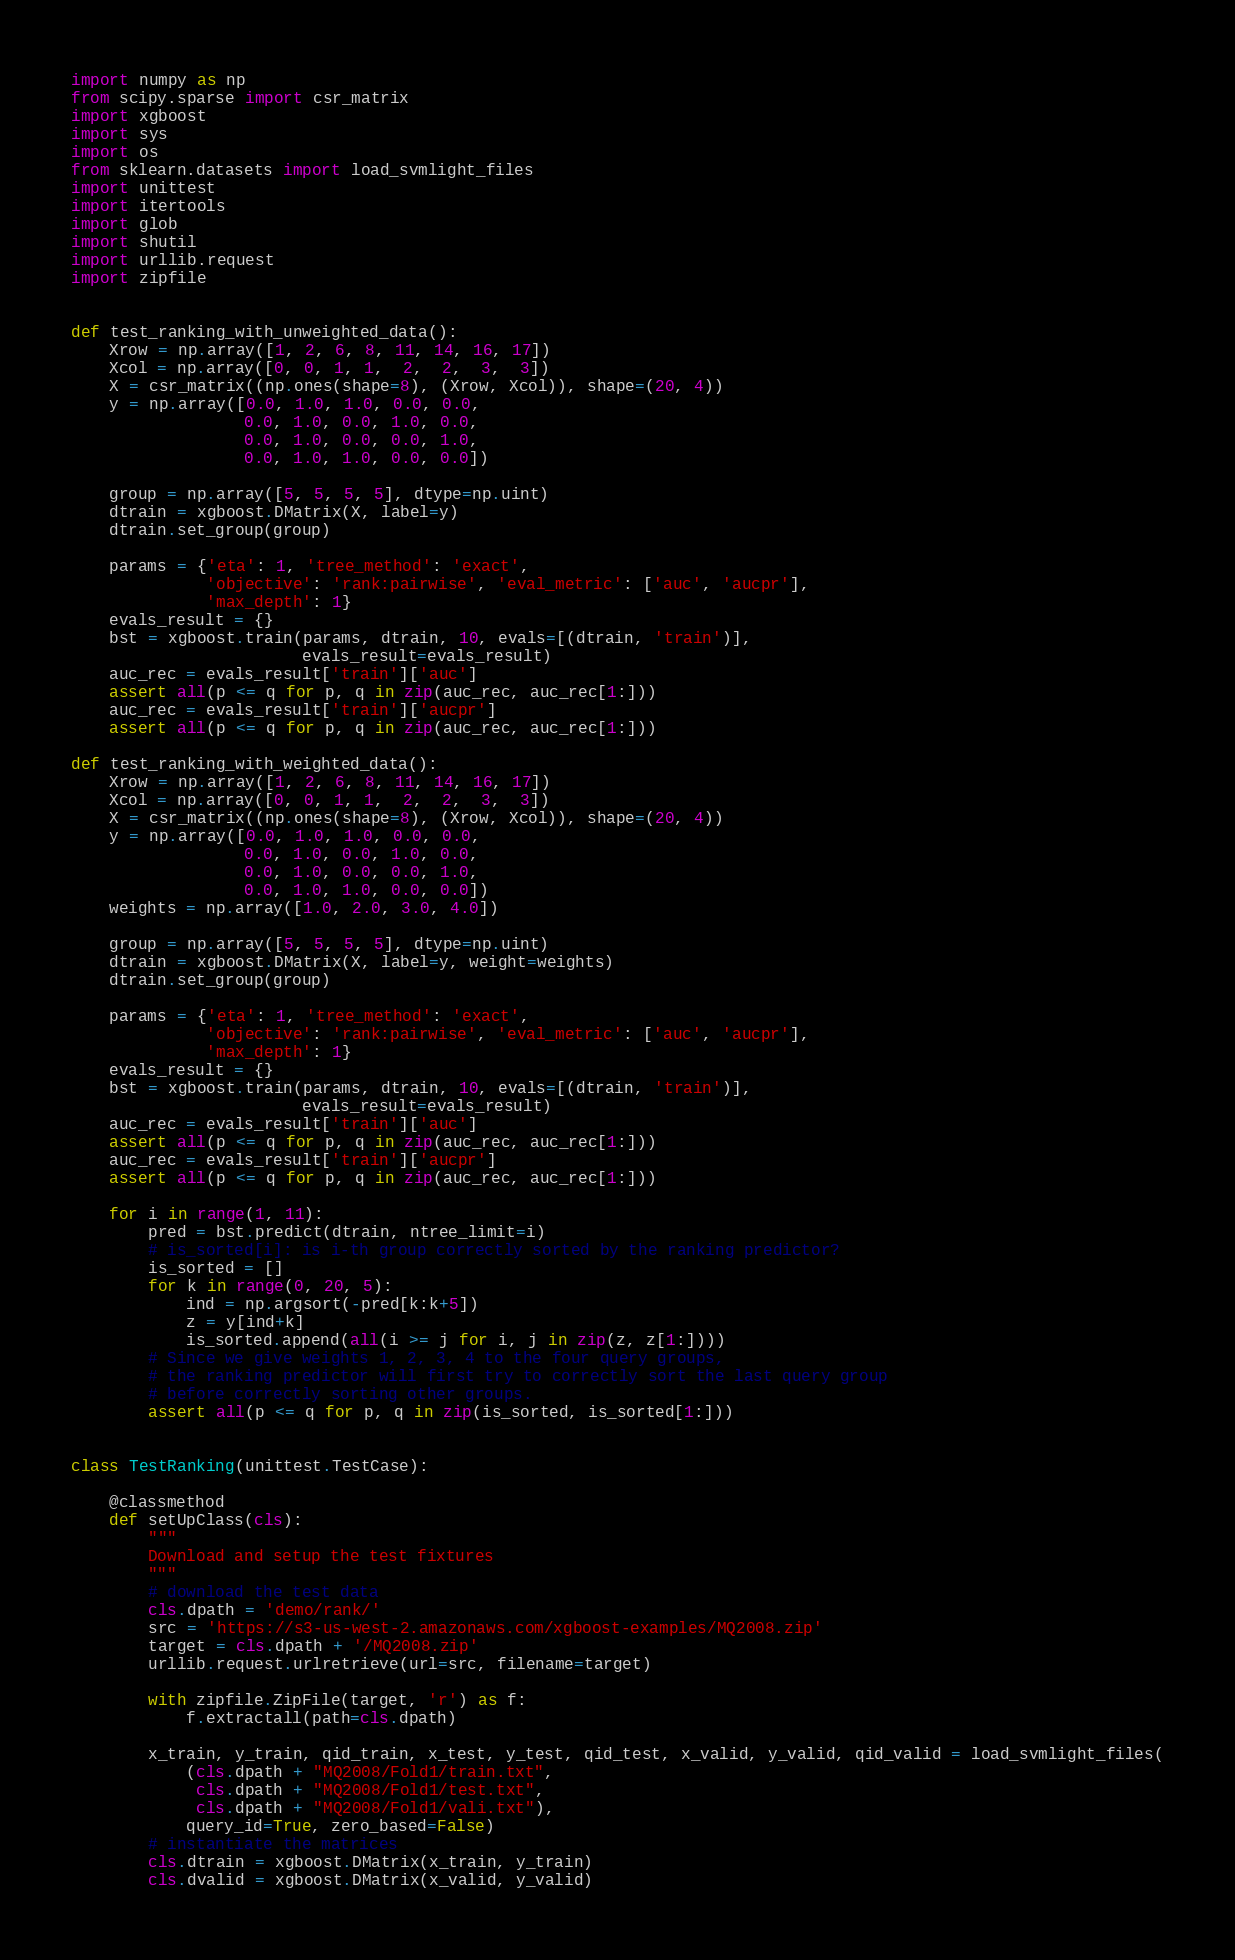<code> <loc_0><loc_0><loc_500><loc_500><_Python_>import numpy as np
from scipy.sparse import csr_matrix
import xgboost
import sys
import os
from sklearn.datasets import load_svmlight_files
import unittest
import itertools
import glob
import shutil
import urllib.request
import zipfile


def test_ranking_with_unweighted_data():
    Xrow = np.array([1, 2, 6, 8, 11, 14, 16, 17])
    Xcol = np.array([0, 0, 1, 1,  2,  2,  3,  3])
    X = csr_matrix((np.ones(shape=8), (Xrow, Xcol)), shape=(20, 4))
    y = np.array([0.0, 1.0, 1.0, 0.0, 0.0,
                  0.0, 1.0, 0.0, 1.0, 0.0,
                  0.0, 1.0, 0.0, 0.0, 1.0,
                  0.0, 1.0, 1.0, 0.0, 0.0])

    group = np.array([5, 5, 5, 5], dtype=np.uint)
    dtrain = xgboost.DMatrix(X, label=y)
    dtrain.set_group(group)

    params = {'eta': 1, 'tree_method': 'exact',
              'objective': 'rank:pairwise', 'eval_metric': ['auc', 'aucpr'],
              'max_depth': 1}
    evals_result = {}
    bst = xgboost.train(params, dtrain, 10, evals=[(dtrain, 'train')],
                        evals_result=evals_result)
    auc_rec = evals_result['train']['auc']
    assert all(p <= q for p, q in zip(auc_rec, auc_rec[1:]))
    auc_rec = evals_result['train']['aucpr']
    assert all(p <= q for p, q in zip(auc_rec, auc_rec[1:]))

def test_ranking_with_weighted_data():
    Xrow = np.array([1, 2, 6, 8, 11, 14, 16, 17])
    Xcol = np.array([0, 0, 1, 1,  2,  2,  3,  3])
    X = csr_matrix((np.ones(shape=8), (Xrow, Xcol)), shape=(20, 4))
    y = np.array([0.0, 1.0, 1.0, 0.0, 0.0,
                  0.0, 1.0, 0.0, 1.0, 0.0,
                  0.0, 1.0, 0.0, 0.0, 1.0,
                  0.0, 1.0, 1.0, 0.0, 0.0])
    weights = np.array([1.0, 2.0, 3.0, 4.0])

    group = np.array([5, 5, 5, 5], dtype=np.uint)
    dtrain = xgboost.DMatrix(X, label=y, weight=weights)
    dtrain.set_group(group)

    params = {'eta': 1, 'tree_method': 'exact',
              'objective': 'rank:pairwise', 'eval_metric': ['auc', 'aucpr'],
              'max_depth': 1}
    evals_result = {}
    bst = xgboost.train(params, dtrain, 10, evals=[(dtrain, 'train')],
                        evals_result=evals_result)
    auc_rec = evals_result['train']['auc']
    assert all(p <= q for p, q in zip(auc_rec, auc_rec[1:]))
    auc_rec = evals_result['train']['aucpr']
    assert all(p <= q for p, q in zip(auc_rec, auc_rec[1:]))

    for i in range(1, 11):
        pred = bst.predict(dtrain, ntree_limit=i)
        # is_sorted[i]: is i-th group correctly sorted by the ranking predictor?
        is_sorted = []
        for k in range(0, 20, 5):
            ind = np.argsort(-pred[k:k+5])
            z = y[ind+k]
            is_sorted.append(all(i >= j for i, j in zip(z, z[1:])))
        # Since we give weights 1, 2, 3, 4 to the four query groups,
        # the ranking predictor will first try to correctly sort the last query group
        # before correctly sorting other groups.
        assert all(p <= q for p, q in zip(is_sorted, is_sorted[1:]))


class TestRanking(unittest.TestCase):

    @classmethod
    def setUpClass(cls):
        """
        Download and setup the test fixtures
        """
        # download the test data
        cls.dpath = 'demo/rank/'
        src = 'https://s3-us-west-2.amazonaws.com/xgboost-examples/MQ2008.zip'
        target = cls.dpath + '/MQ2008.zip'
        urllib.request.urlretrieve(url=src, filename=target)

        with zipfile.ZipFile(target, 'r') as f:
            f.extractall(path=cls.dpath)

        x_train, y_train, qid_train, x_test, y_test, qid_test, x_valid, y_valid, qid_valid = load_svmlight_files(
            (cls.dpath + "MQ2008/Fold1/train.txt",
             cls.dpath + "MQ2008/Fold1/test.txt",
             cls.dpath + "MQ2008/Fold1/vali.txt"),
            query_id=True, zero_based=False)
        # instantiate the matrices
        cls.dtrain = xgboost.DMatrix(x_train, y_train)
        cls.dvalid = xgboost.DMatrix(x_valid, y_valid)</code> 